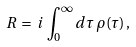Convert formula to latex. <formula><loc_0><loc_0><loc_500><loc_500>R \, = \, i \, \int _ { 0 } ^ { \infty } d \tau \, \rho ( \tau ) \, ,</formula> 